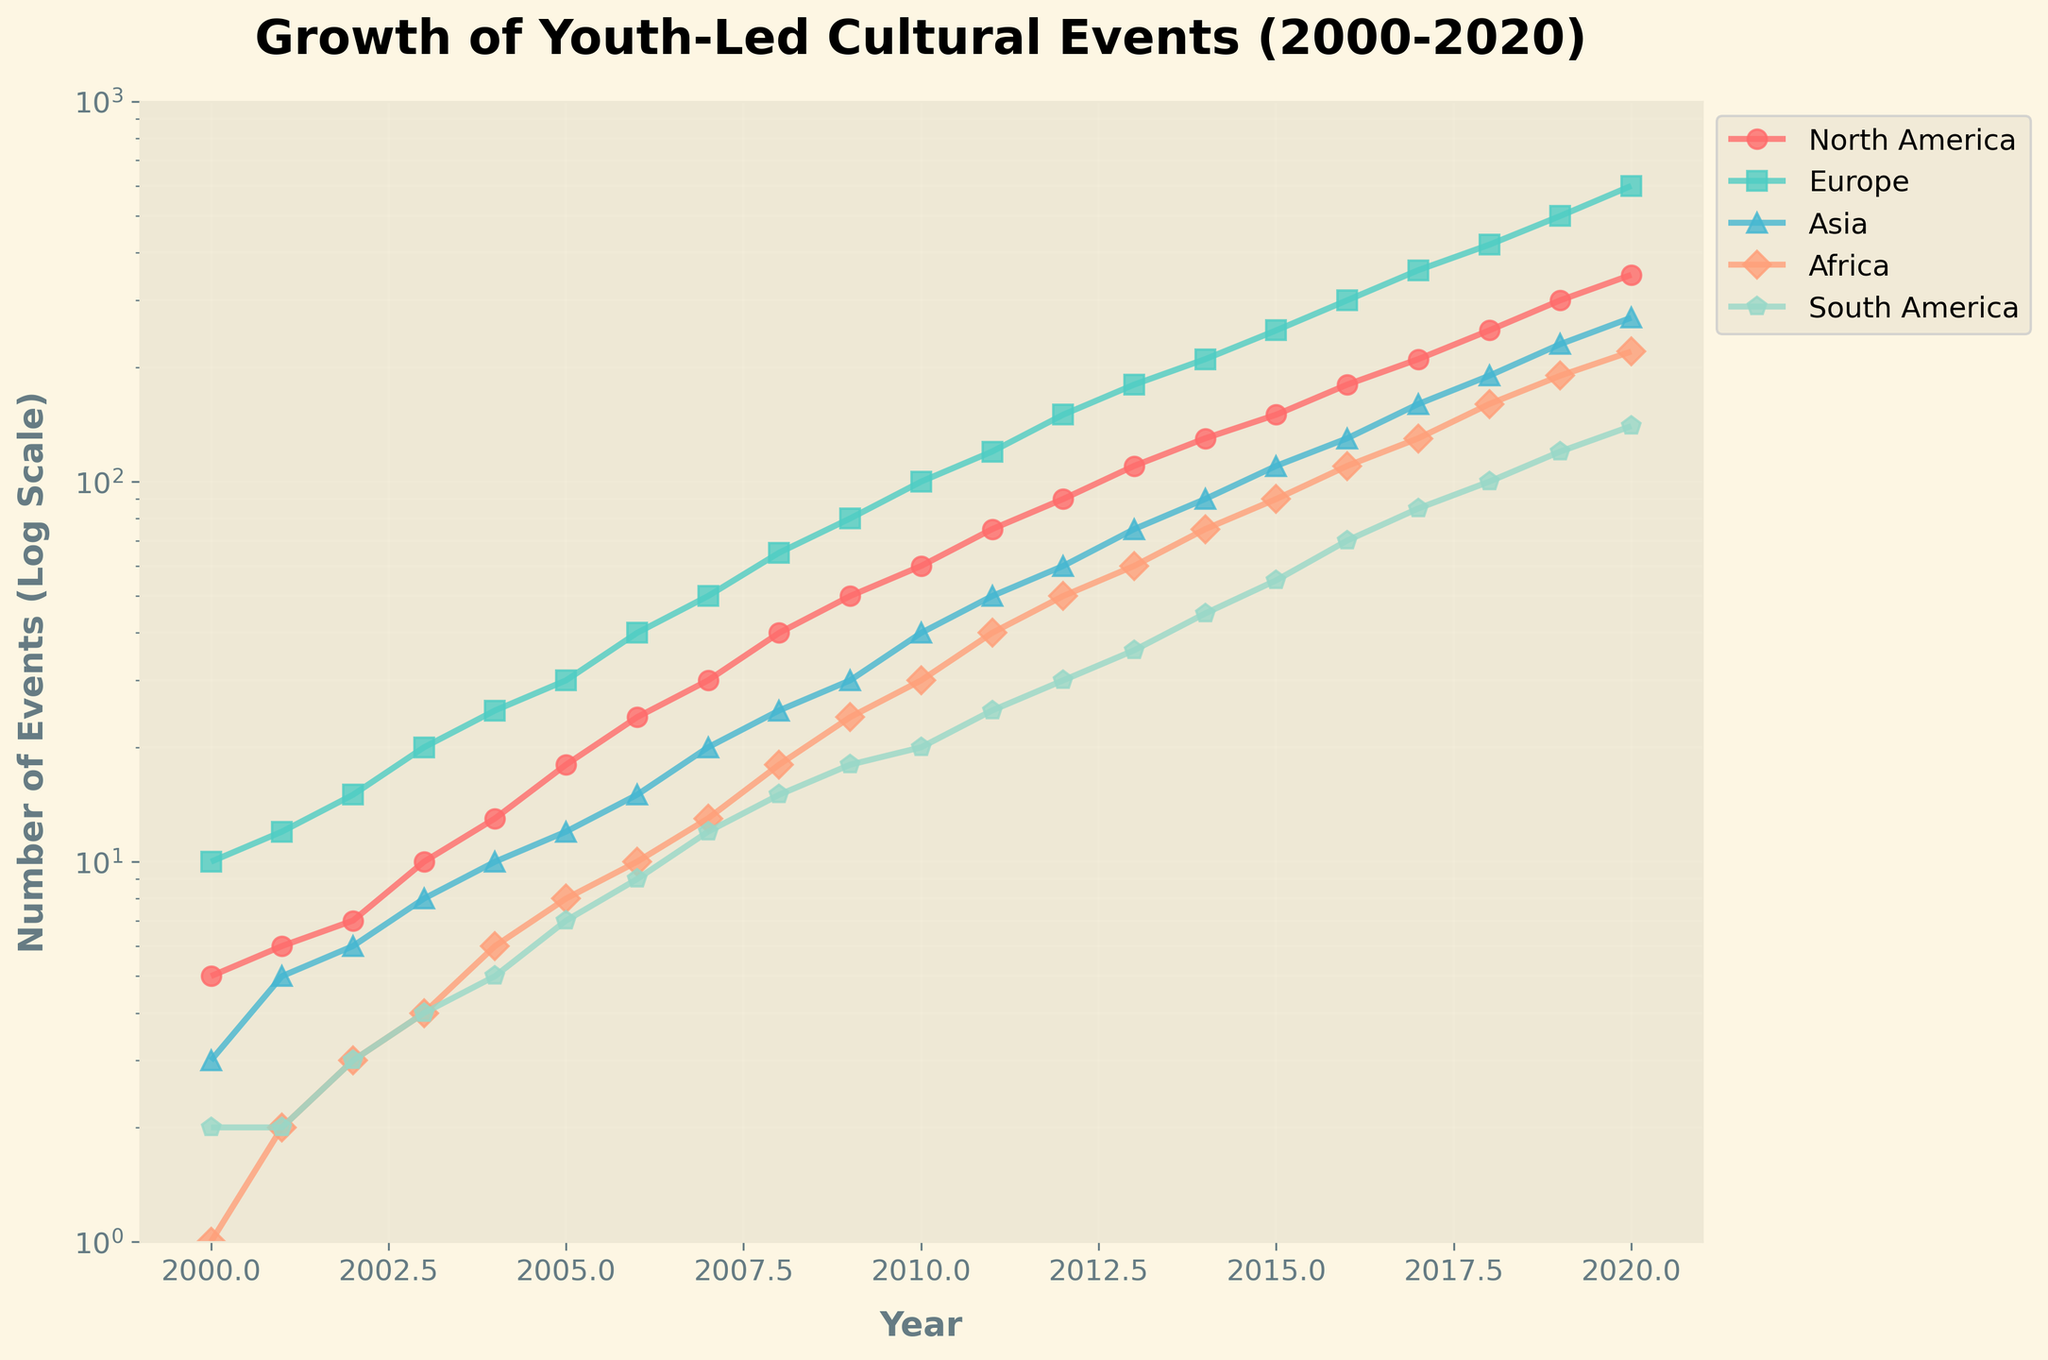What's the title of the plot? The title is clearly displayed at the top of the plot in a larger and bolder font. It reads "Growth of Youth-Led Cultural Events (2000-2020)".
Answer: Growth of Youth-Led Cultural Events (2000-2020) What is the y-axis demonstrating in this plot? The y-axis shows the number of events on a log scale, as indicated by the label "Number of Events (Log Scale)".
Answer: Number of Events (Log Scale) Which region had the highest number of youth-led cultural events in 2020? By tracing the line corresponding to 2020 on the x-axis and finding the highest point, it is clear that North America had the highest number of events in 2020, reaching 350 events.
Answer: North America In which year did Europe surpass 100 youth-led cultural events? Looking at the line representing Europe, we see that it crosses the 100 mark on the y-axis around 2010.
Answer: 2010 How many regions had more than 50 youth-led cultural events in 2011? Tracing the year 2011 on the x-axis and looking across the corresponding y-axis values, three regions (North America, Europe, and Asia) had more than 50 events.
Answer: Three Which region had the fastest growth in youth-led cultural events from 2000 to 2020? Comparing the steepness of the lines, Europe's line appears steepest, indicating Europe's events grew fastest.
Answer: Europe What was the trend of youth-led cultural events in South America from 2000 to 2020? The line for South America consistently increased from 2000 (2 events) to 2020 (140 events), showing steady growth over time.
Answer: Steady increase By how much did the number of youth-led events in Asia increase from 2015 to 2019? The line for Asia shows values starting at 110 in 2015 to 230 in 2019, leading to an increase of 230 - 110 = 120 events.
Answer: 120 events Which region experienced the slowest growth in the initial five years (2000-2005)? Observing the slopes of the lines between 2000 to 2005, Africa shows the slowest growth, moving from 1 to 8 events.
Answer: Africa What is unique about the lines plotted on the graph? The lines are plotted with different colors and markers to distinguish between regions and are plotted on a logarithmic scale, which is unique. The log scale greatly enhances the visualization of growth trends over a vast range of values.
Answer: Different colors, different markers, log scale 